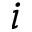<formula> <loc_0><loc_0><loc_500><loc_500>i</formula> 